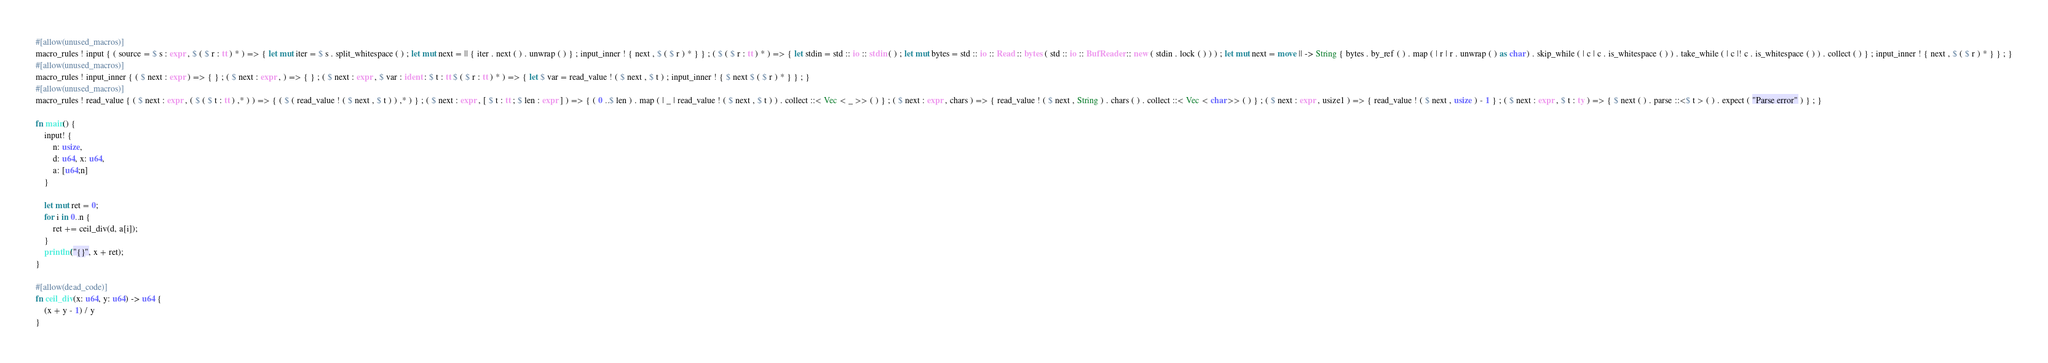Convert code to text. <code><loc_0><loc_0><loc_500><loc_500><_Rust_>#[allow(unused_macros)]
macro_rules ! input { ( source = $ s : expr , $ ( $ r : tt ) * ) => { let mut iter = $ s . split_whitespace ( ) ; let mut next = || { iter . next ( ) . unwrap ( ) } ; input_inner ! { next , $ ( $ r ) * } } ; ( $ ( $ r : tt ) * ) => { let stdin = std :: io :: stdin ( ) ; let mut bytes = std :: io :: Read :: bytes ( std :: io :: BufReader :: new ( stdin . lock ( ) ) ) ; let mut next = move || -> String { bytes . by_ref ( ) . map ( | r | r . unwrap ( ) as char ) . skip_while ( | c | c . is_whitespace ( ) ) . take_while ( | c |! c . is_whitespace ( ) ) . collect ( ) } ; input_inner ! { next , $ ( $ r ) * } } ; }
#[allow(unused_macros)]
macro_rules ! input_inner { ( $ next : expr ) => { } ; ( $ next : expr , ) => { } ; ( $ next : expr , $ var : ident : $ t : tt $ ( $ r : tt ) * ) => { let $ var = read_value ! ( $ next , $ t ) ; input_inner ! { $ next $ ( $ r ) * } } ; }
#[allow(unused_macros)]
macro_rules ! read_value { ( $ next : expr , ( $ ( $ t : tt ) ,* ) ) => { ( $ ( read_value ! ( $ next , $ t ) ) ,* ) } ; ( $ next : expr , [ $ t : tt ; $ len : expr ] ) => { ( 0 ..$ len ) . map ( | _ | read_value ! ( $ next , $ t ) ) . collect ::< Vec < _ >> ( ) } ; ( $ next : expr , chars ) => { read_value ! ( $ next , String ) . chars ( ) . collect ::< Vec < char >> ( ) } ; ( $ next : expr , usize1 ) => { read_value ! ( $ next , usize ) - 1 } ; ( $ next : expr , $ t : ty ) => { $ next ( ) . parse ::<$ t > ( ) . expect ( "Parse error" ) } ; }

fn main() {
    input! {
        n: usize,
        d: u64, x: u64,
        a: [u64;n]
    }

    let mut ret = 0;
    for i in 0..n {
        ret += ceil_div(d, a[i]);
    }
    println!("{}", x + ret);
}

#[allow(dead_code)]
fn ceil_div(x: u64, y: u64) -> u64 {
    (x + y - 1) / y
}</code> 